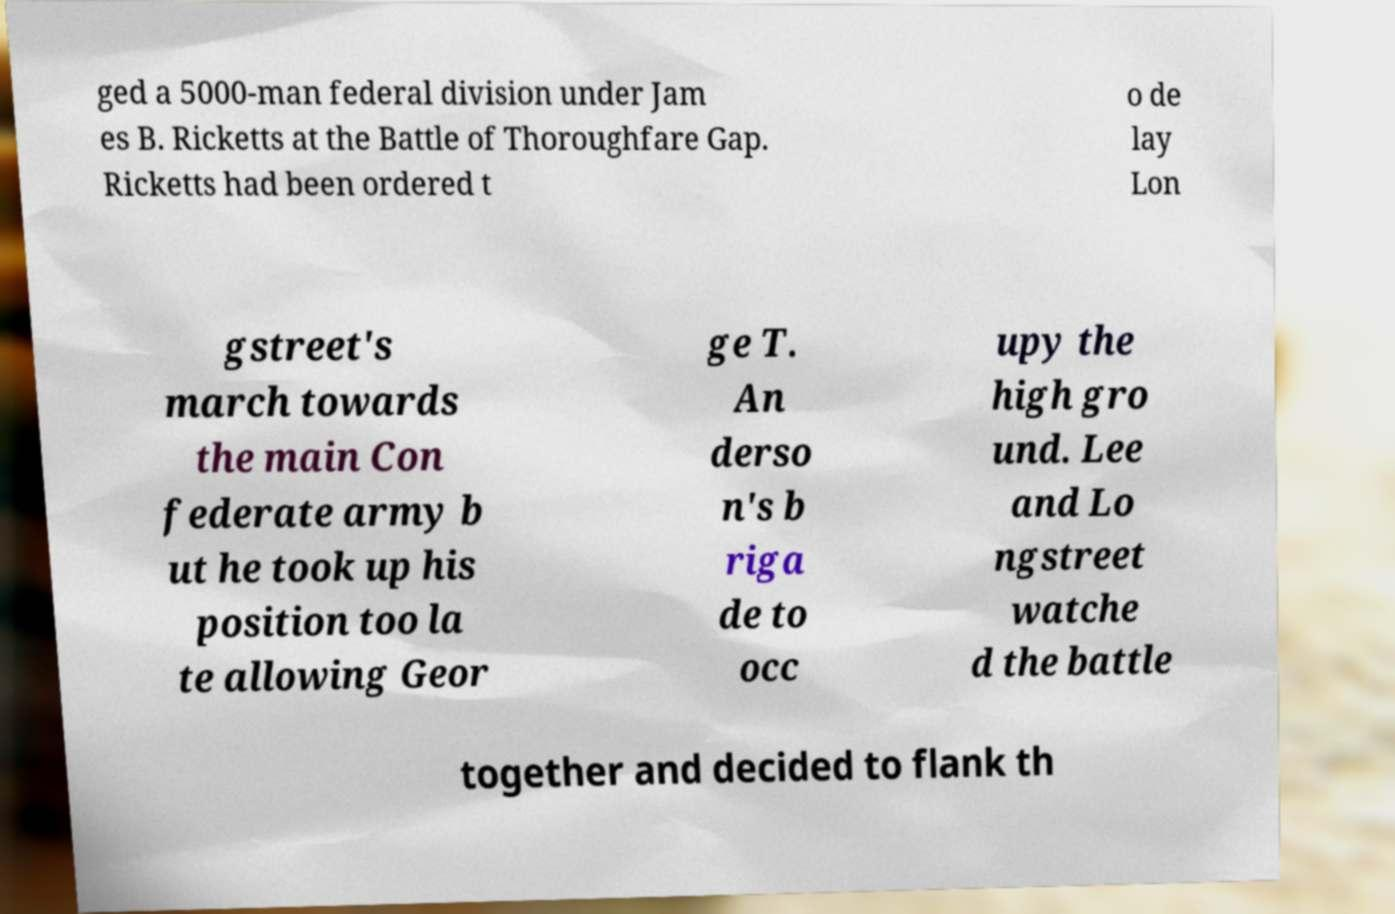Please identify and transcribe the text found in this image. ged a 5000-man federal division under Jam es B. Ricketts at the Battle of Thoroughfare Gap. Ricketts had been ordered t o de lay Lon gstreet's march towards the main Con federate army b ut he took up his position too la te allowing Geor ge T. An derso n's b riga de to occ upy the high gro und. Lee and Lo ngstreet watche d the battle together and decided to flank th 